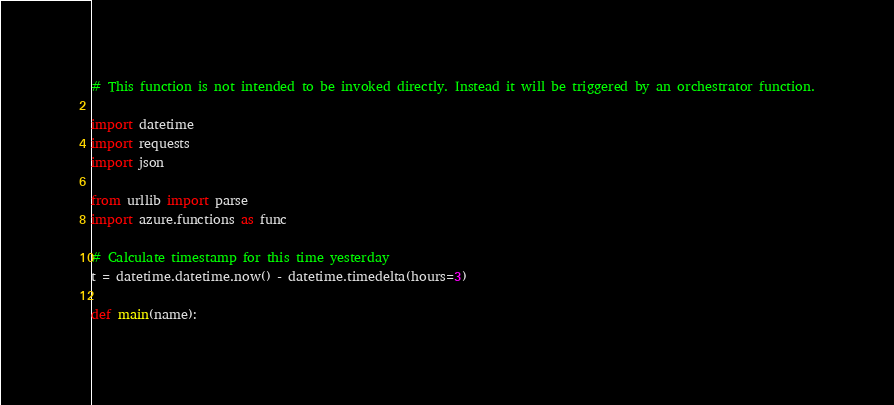Convert code to text. <code><loc_0><loc_0><loc_500><loc_500><_Python_># This function is not intended to be invoked directly. Instead it will be triggered by an orchestrator function.

import datetime
import requests
import json

from urllib import parse
import azure.functions as func

# Calculate timestamp for this time yesterday
t = datetime.datetime.now() - datetime.timedelta(hours=3)

def main(name):</code> 